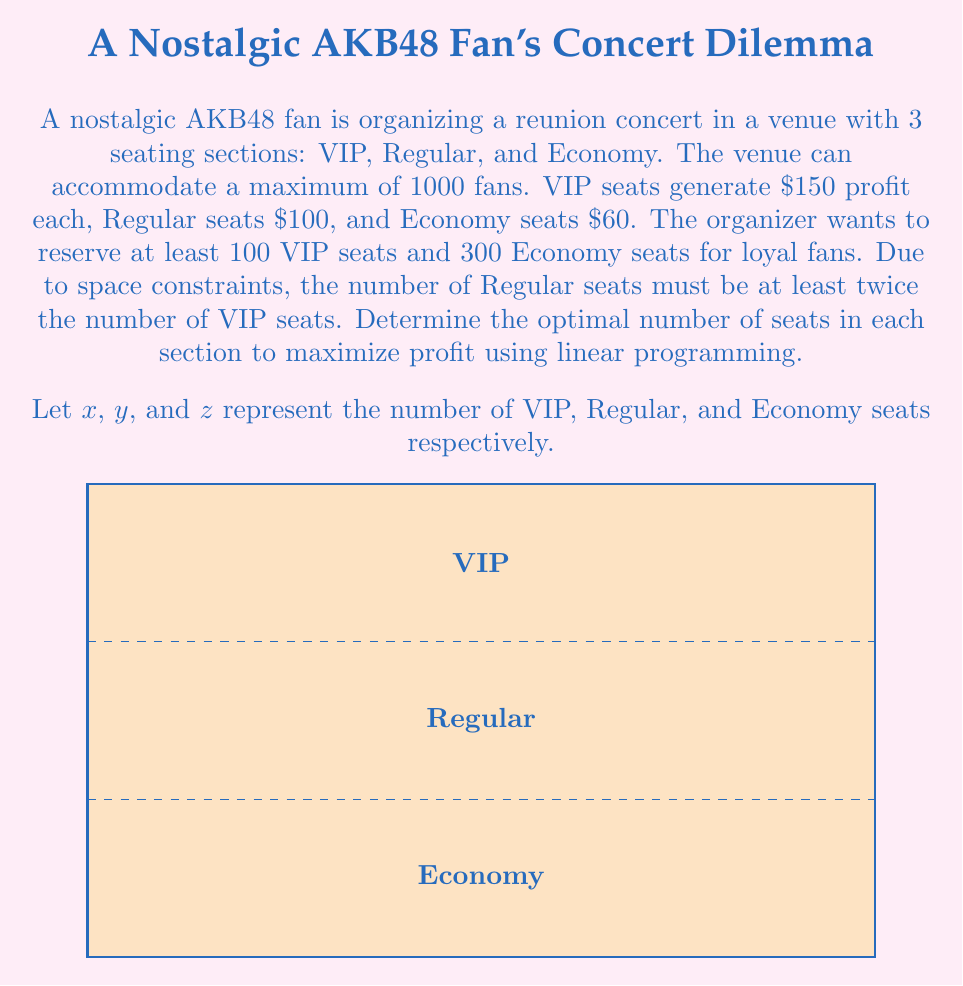What is the answer to this math problem? To solve this linear programming problem, we need to:

1. Define the objective function
2. List the constraints
3. Solve using the simplex method or graphical method

Step 1: Objective function
Maximize profit: $P = 150x + 100y + 60z$

Step 2: Constraints
a) Total seats: $x + y + z \leq 1000$
b) VIP seat minimum: $x \geq 100$
c) Economy seat minimum: $z \geq 300$
d) Regular seat constraint: $y \geq 2x$
e) Non-negativity: $x, y, z \geq 0$

Step 3: Solving
We can use the simplex method to solve this problem. However, for simplicity, we'll use the corner point method:

1. $(100, 200, 700)$: $P = 15000 + 20000 + 42000 = 77000$
2. $(100, 600, 300)$: $P = 15000 + 60000 + 18000 = 93000$
3. $(200, 400, 400)$: $P = 30000 + 40000 + 24000 = 94000$
4. $(300, 600, 100)$: $P = 45000 + 60000 + 6000 = 111000$

The optimal solution is $(300, 600, 100)$, which maximizes profit at $111,000.
Answer: VIP: 300, Regular: 600, Economy: 100 